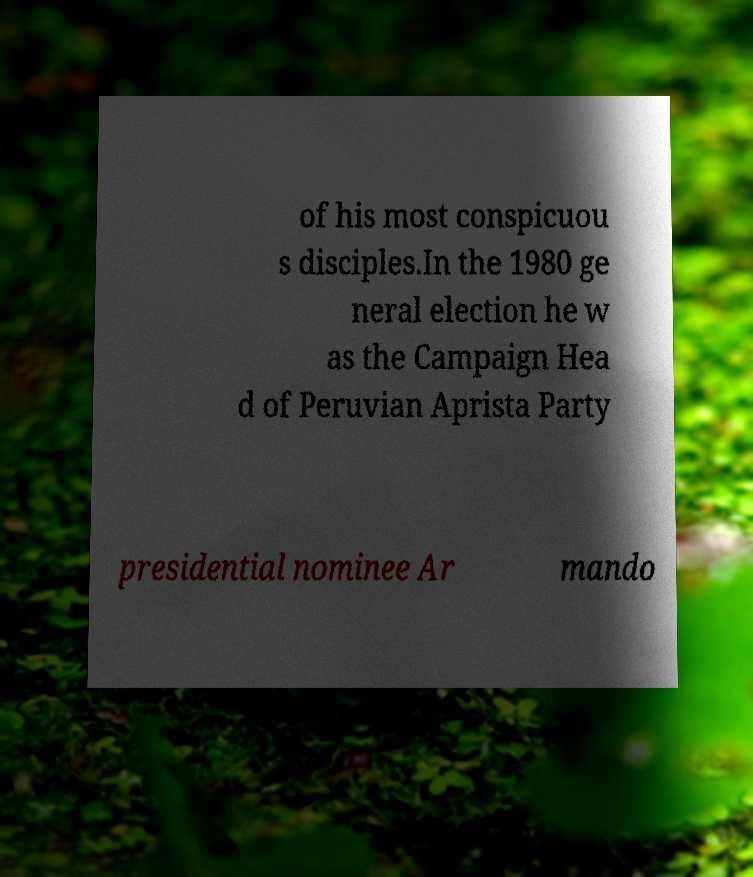I need the written content from this picture converted into text. Can you do that? of his most conspicuou s disciples.In the 1980 ge neral election he w as the Campaign Hea d of Peruvian Aprista Party presidential nominee Ar mando 